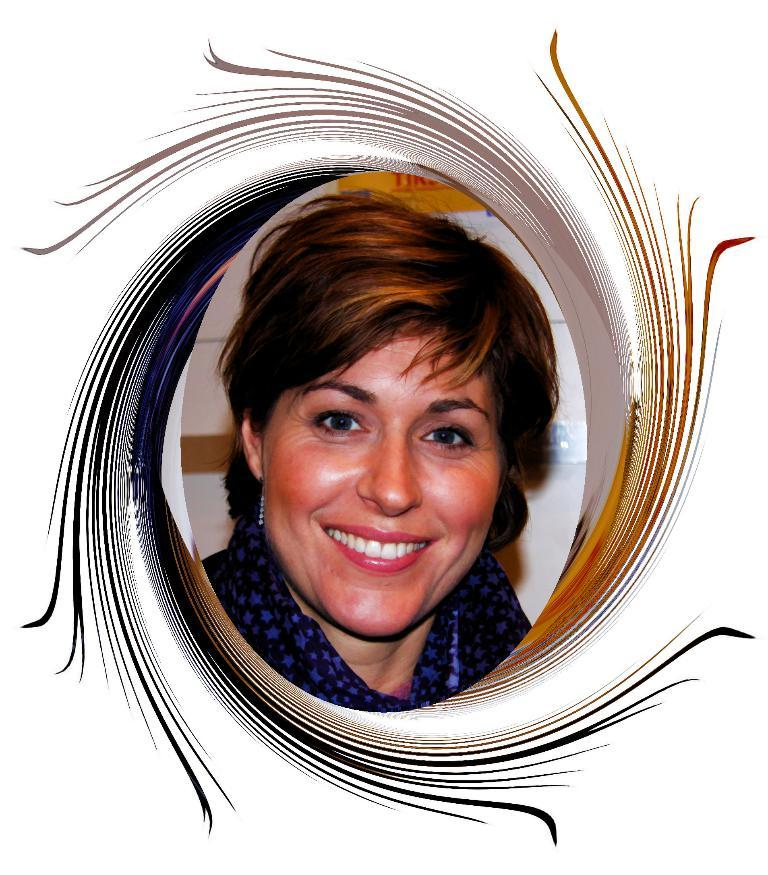What is the main subject of the image? There is a face of a woman in the image. What expression does the woman have? The woman is smiling. What is visible behind the woman in the image? There is a wall behind the woman. How is the image framed? The photo has a border around it. What type of sign can be seen in the woman's hand in the image? There is no sign visible in the woman's hand in the image. Is the woman holding a gun in the image? No, the woman is not holding a gun in the image. What is the woman using to hold a can in the image? There is no can present in the image, so it cannot be determined what the woman might be using to hold it. 